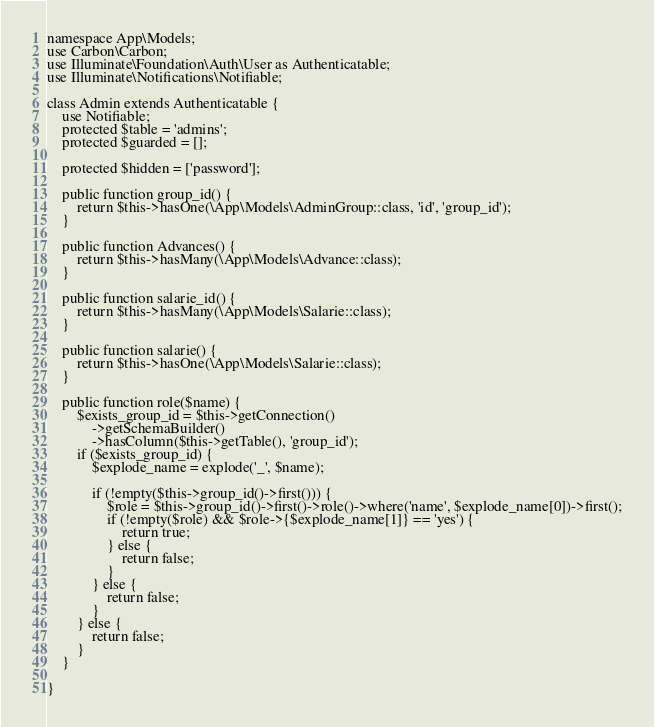<code> <loc_0><loc_0><loc_500><loc_500><_PHP_>namespace App\Models;
use Carbon\Carbon;
use Illuminate\Foundation\Auth\User as Authenticatable;
use Illuminate\Notifications\Notifiable;

class Admin extends Authenticatable {
	use Notifiable;
	protected $table = 'admins';
	protected $guarded = [];

	protected $hidden = ['password'];

	public function group_id() {
		return $this->hasOne(\App\Models\AdminGroup::class, 'id', 'group_id');
	}

    public function Advances() {
		return $this->hasMany(\App\Models\Advance::class);
	}

    public function salarie_id() {
		return $this->hasMany(\App\Models\Salarie::class);
	}

    public function salarie() {
		return $this->hasOne(\App\Models\Salarie::class);
	}

	public function role($name) {
		$exists_group_id = $this->getConnection()
			->getSchemaBuilder()
			->hasColumn($this->getTable(), 'group_id');
		if ($exists_group_id) {
			$explode_name = explode('_', $name);

			if (!empty($this->group_id()->first())) {
				$role = $this->group_id()->first()->role()->where('name', $explode_name[0])->first();
				if (!empty($role) && $role->{$explode_name[1]} == 'yes') {
					return true;
				} else {
					return false;
				}
			} else {
				return false;
			}
		} else {
			return false;
		}
	}

}
</code> 